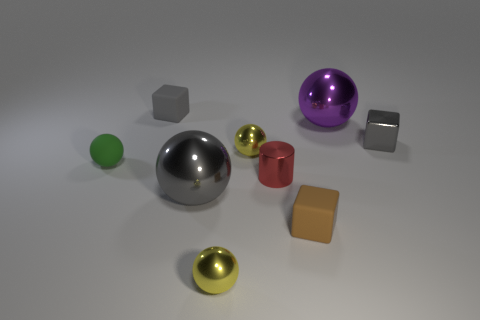Is there a gray object of the same shape as the brown matte thing?
Ensure brevity in your answer.  Yes. Does the rubber thing that is behind the metallic block have the same shape as the brown rubber thing that is in front of the small red cylinder?
Offer a terse response. Yes. There is a brown object that is the same size as the green sphere; what is its material?
Ensure brevity in your answer.  Rubber. What number of other things are there of the same material as the green thing
Keep it short and to the point. 2. The gray metallic thing right of the large metal object in front of the cylinder is what shape?
Your response must be concise. Cube. How many objects are small gray metallic blocks or small gray objects that are on the left side of the small red object?
Offer a terse response. 2. How many other things are there of the same color as the metallic block?
Offer a terse response. 2. What number of gray objects are either tiny spheres or metal cylinders?
Your answer should be compact. 0. Is there a small metal thing to the right of the gray block in front of the tiny gray object that is behind the tiny gray metal block?
Your answer should be very brief. No. Is there anything else that is the same size as the metal cylinder?
Offer a terse response. Yes. 